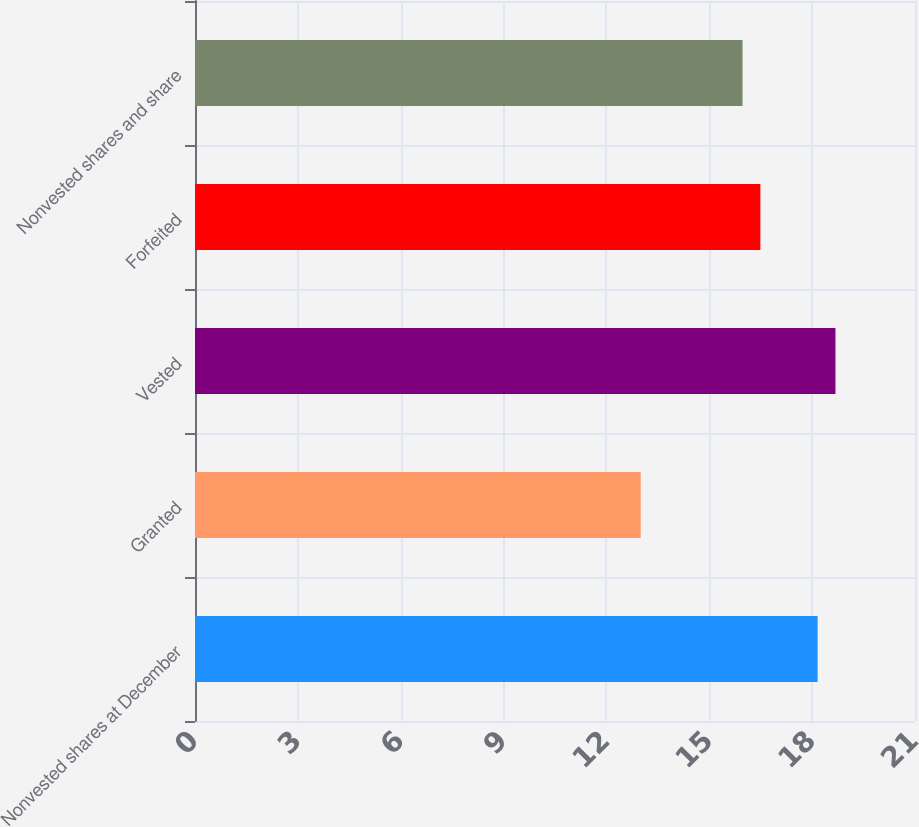Convert chart to OTSL. <chart><loc_0><loc_0><loc_500><loc_500><bar_chart><fcel>Nonvested shares at December<fcel>Granted<fcel>Vested<fcel>Forfeited<fcel>Nonvested shares and share<nl><fcel>18.16<fcel>13<fcel>18.68<fcel>16.49<fcel>15.97<nl></chart> 